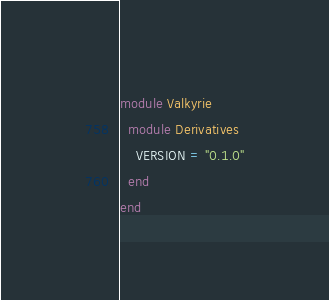Convert code to text. <code><loc_0><loc_0><loc_500><loc_500><_Ruby_>module Valkyrie
  module Derivatives
    VERSION = "0.1.0"
  end
end
</code> 